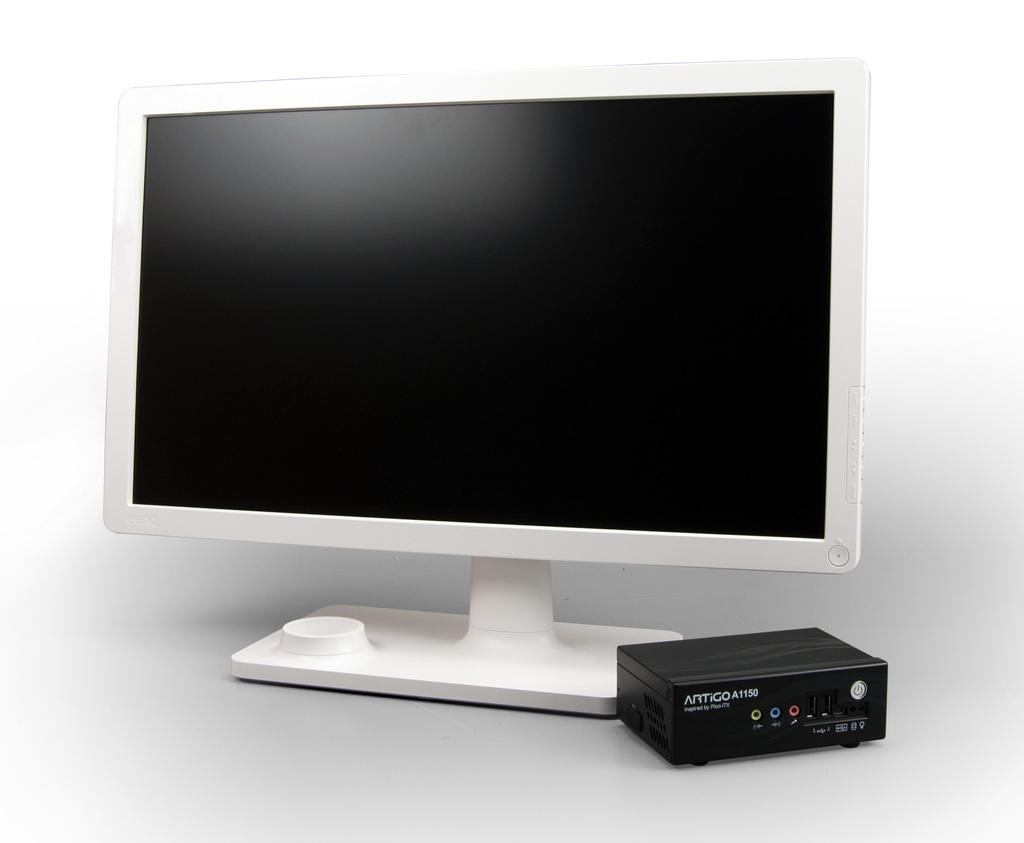<image>
Summarize the visual content of the image. A device labeled ARTiGO A1150 sits next to a computer monitor. 